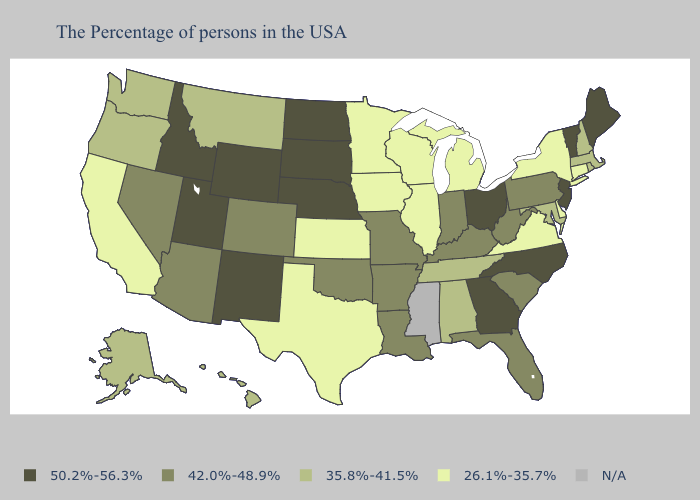Does the first symbol in the legend represent the smallest category?
Concise answer only. No. Does Oklahoma have the highest value in the South?
Quick response, please. No. Which states have the lowest value in the South?
Answer briefly. Delaware, Virginia, Texas. Name the states that have a value in the range 26.1%-35.7%?
Short answer required. Connecticut, New York, Delaware, Virginia, Michigan, Wisconsin, Illinois, Minnesota, Iowa, Kansas, Texas, California. Name the states that have a value in the range N/A?
Write a very short answer. Mississippi. What is the value of North Dakota?
Keep it brief. 50.2%-56.3%. What is the value of Indiana?
Concise answer only. 42.0%-48.9%. Name the states that have a value in the range 35.8%-41.5%?
Keep it brief. Massachusetts, Rhode Island, New Hampshire, Maryland, Alabama, Tennessee, Montana, Washington, Oregon, Alaska, Hawaii. What is the value of Tennessee?
Quick response, please. 35.8%-41.5%. What is the highest value in states that border Montana?
Answer briefly. 50.2%-56.3%. Name the states that have a value in the range 26.1%-35.7%?
Concise answer only. Connecticut, New York, Delaware, Virginia, Michigan, Wisconsin, Illinois, Minnesota, Iowa, Kansas, Texas, California. Name the states that have a value in the range 26.1%-35.7%?
Keep it brief. Connecticut, New York, Delaware, Virginia, Michigan, Wisconsin, Illinois, Minnesota, Iowa, Kansas, Texas, California. Which states have the lowest value in the South?
Quick response, please. Delaware, Virginia, Texas. Name the states that have a value in the range N/A?
Give a very brief answer. Mississippi. 